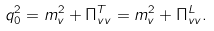Convert formula to latex. <formula><loc_0><loc_0><loc_500><loc_500>q _ { 0 } ^ { 2 } = m _ { v } ^ { 2 } + \Pi _ { v v } ^ { T } = m _ { v } ^ { 2 } + \Pi _ { v v } ^ { L } .</formula> 